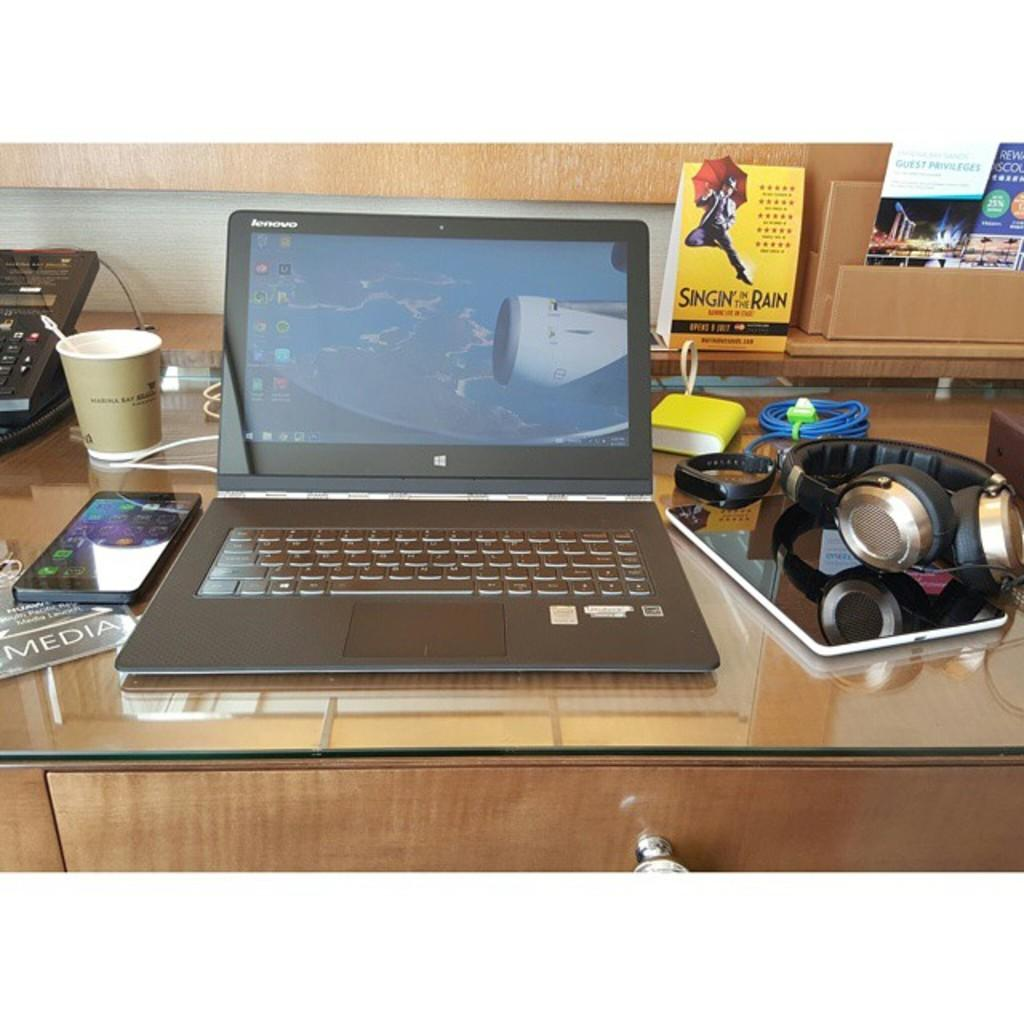What piece of furniture is present in the image? There is a table in the image. What electronic device is on the table? There is a laptop on the table. What other electronic device is on the table? There is a mobile on the table. What type of container is on the table? There is a glass on the table. What is the headset used for in the image? The headset is used for listening or communicating. How does the wealth of the person in the image affect the order of the items on the table? The image does not provide any information about the person's wealth or the order of the items on the table. 